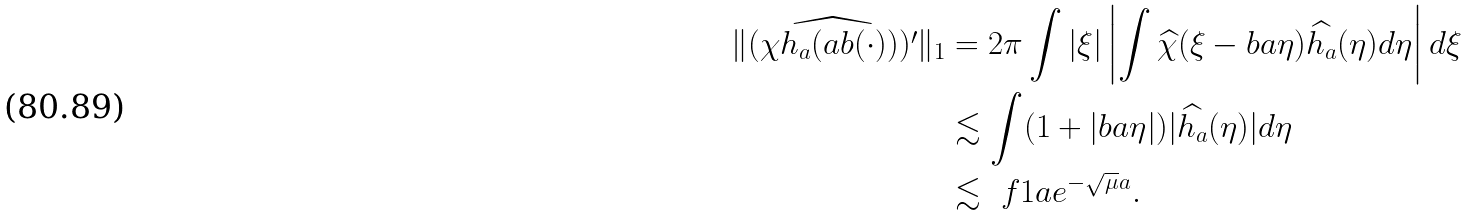Convert formula to latex. <formula><loc_0><loc_0><loc_500><loc_500>\| \widehat { ( \chi h _ { a } ( a b ( \cdot ) ) ) ^ { \prime } } \| _ { 1 } & = 2 \pi \int | \xi | \left | \int \widehat { \chi } ( \xi - b a \eta ) \widehat { h _ { a } } ( \eta ) d \eta \right | d \xi \\ & \lesssim \int ( 1 + | b a \eta | ) | \widehat { h _ { a } } ( \eta ) | d \eta \\ & \lesssim \ f { 1 } { a } e ^ { - \sqrt { \mu } a } .</formula> 